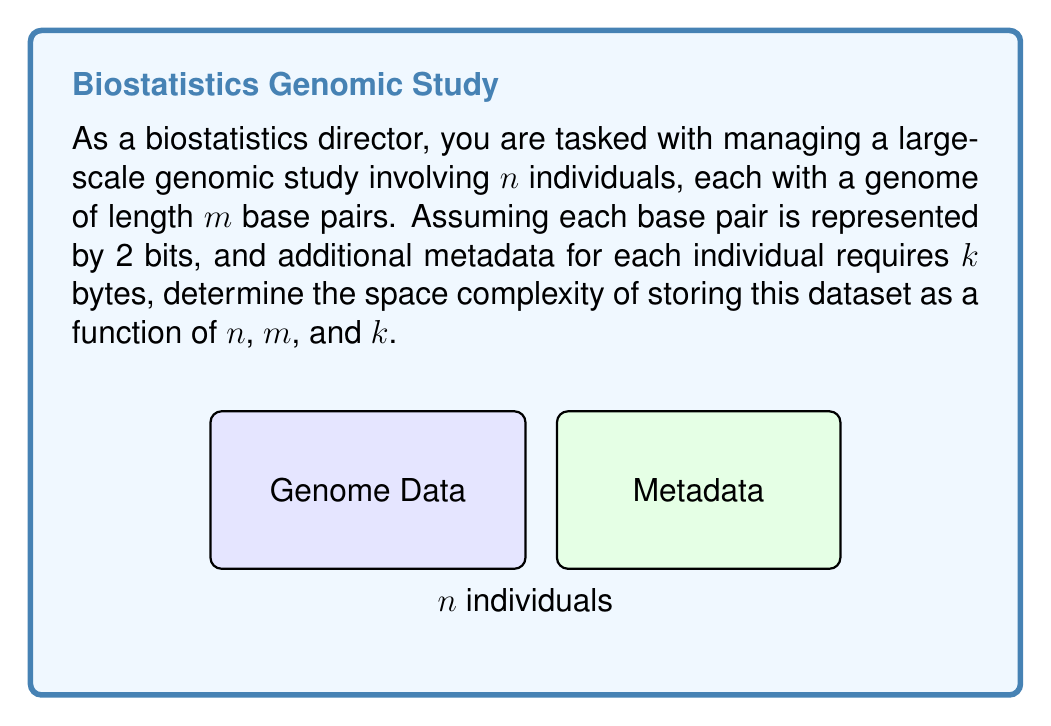Provide a solution to this math problem. To determine the space complexity, we need to calculate the total storage required:

1. Storage for genomic data:
   - Each base pair requires 2 bits
   - Each individual has $m$ base pairs
   - Total bits for one individual's genome: $2m$
   - Total bits for $n$ individuals: $2mn$
   - Converting to bytes: $\frac{2mn}{8} = \frac{mn}{4}$ bytes

2. Storage for metadata:
   - Each individual requires $k$ bytes of metadata
   - Total metadata storage: $nk$ bytes

3. Total storage:
   $$\text{Total storage} = \frac{mn}{4} + nk \text{ bytes}$$

4. Simplifying the expression:
   $$\text{Total storage} = n(\frac{m}{4} + k) \text{ bytes}$$

5. Space complexity analysis:
   - The storage grows linearly with $n$
   - It also grows linearly with $m$ and $k$
   - Therefore, the space complexity is $O(n(m+k))$
Answer: $O(n(m+k))$ 